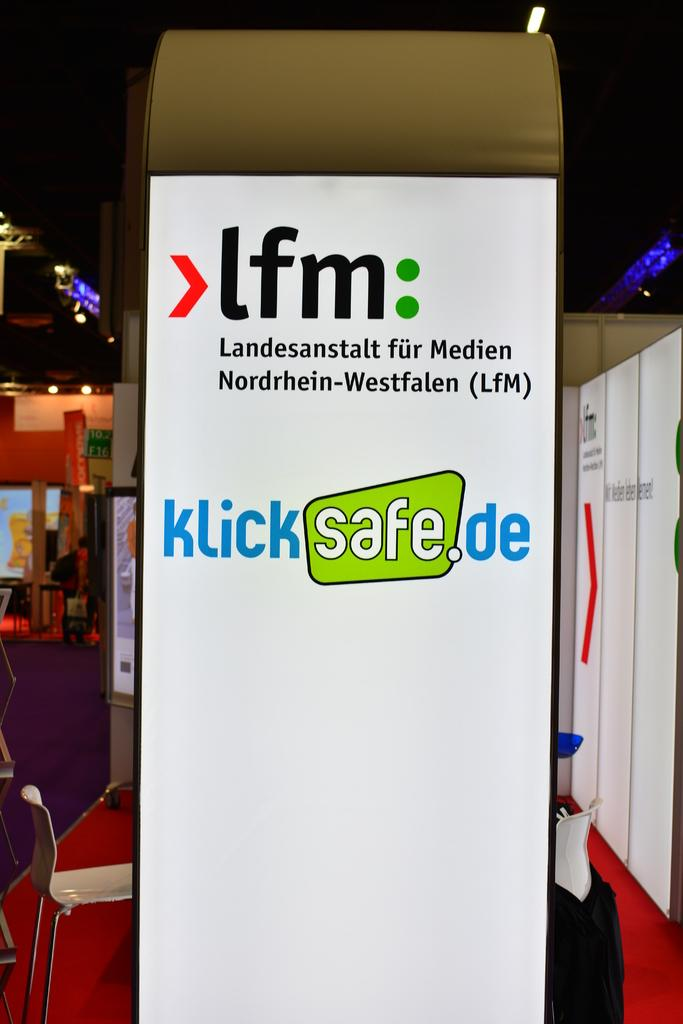<image>
Summarize the visual content of the image. A sign on the side of a metal detector urges people to visit the klicksafe.de website. 